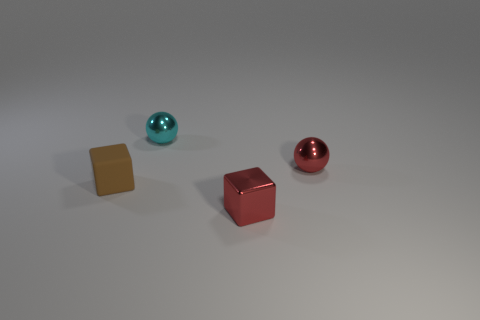There is a red object that is the same shape as the tiny brown thing; what is its size?
Give a very brief answer. Small. How many objects are small metal balls in front of the small cyan thing or tiny objects right of the matte thing?
Offer a terse response. 3. There is a shiny thing behind the tiny sphere that is on the right side of the shiny block; what shape is it?
Make the answer very short. Sphere. Is there any other thing of the same color as the tiny rubber object?
Make the answer very short. No. Is there any other thing that has the same size as the cyan sphere?
Keep it short and to the point. Yes. How many things are tiny cyan objects or gray matte blocks?
Provide a succinct answer. 1. Is there a yellow rubber thing that has the same size as the red metal block?
Make the answer very short. No. What shape is the tiny cyan object?
Your response must be concise. Sphere. Are there more small brown rubber objects on the left side of the metallic block than small red things that are on the right side of the small red sphere?
Keep it short and to the point. Yes. Does the tiny metallic ball that is in front of the cyan sphere have the same color as the object that is in front of the small matte block?
Make the answer very short. Yes. 